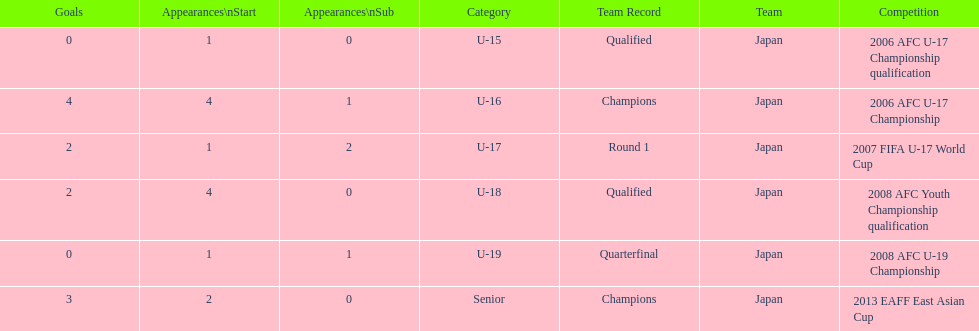What was yoichiro kakitani's first major competition? 2006 AFC U-17 Championship qualification. 